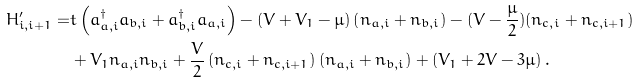Convert formula to latex. <formula><loc_0><loc_0><loc_500><loc_500>H ^ { \prime } _ { i , i + 1 } = & t \left ( a _ { a , i } ^ { \dagger } a _ { b , i } + a _ { b , i } ^ { \dagger } a _ { a , i } \right ) - ( V + V _ { 1 } - \mu ) \left ( n _ { a , i } + n _ { b , i } \right ) - ( V - \frac { \mu } { 2 } ) ( n _ { c , i } + n _ { c , i + 1 } ) \\ & + V _ { 1 } n _ { a , i } n _ { b , i } + \frac { V } { 2 } \left ( n _ { c , i } + n _ { c , i + 1 } \right ) \left ( n _ { a , i } + n _ { b , i } \right ) + \left ( V _ { 1 } + 2 V - 3 \mu \right ) .</formula> 